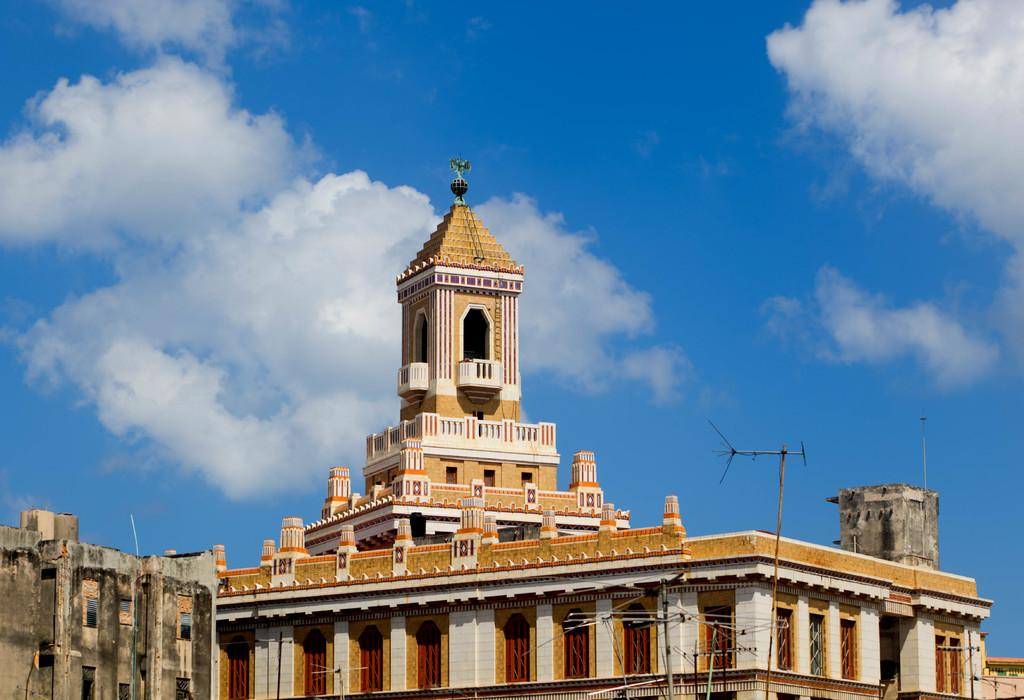What type of structures are present in the image? There are buildings in the image. What is located in front of the buildings? There are antennas in front of the buildings. What can be seen in the sky in the image? There are clouds visible at the top of the image. How many snails can be seen crawling on the buildings in the image? There are no snails present in the image; it only features buildings and antennas. Is there a duck swimming in the clouds at the top of the image? There is no duck present in the image; it only features buildings, antennas, and clouds. 